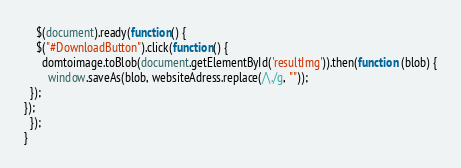<code> <loc_0><loc_0><loc_500><loc_500><_JavaScript_>    $(document).ready(function() {
    $("#DownloadButton").click(function() {
      domtoimage.toBlob(document.getElementById('resultImg')).then(function (blob) {
        window.saveAs(blob, websiteAdress.replace(/\./g, ""));
  });
});
  });
}</code> 